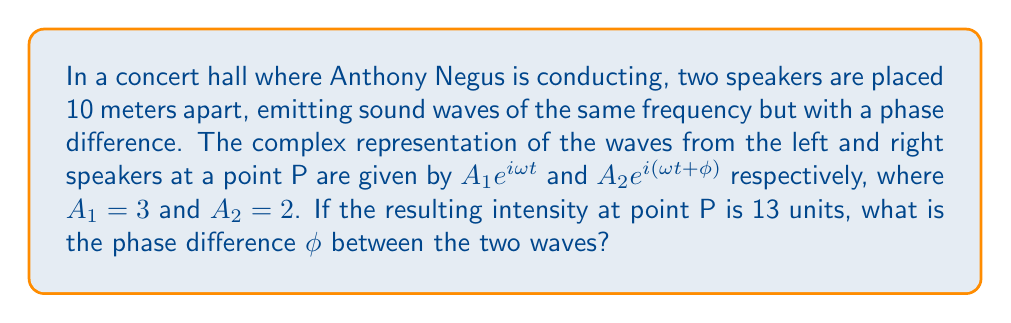Teach me how to tackle this problem. Let's approach this step-by-step:

1) The resulting wave at point P is the sum of the two waves:
   $$A_{total} = A_1e^{i\omega t} + A_2e^{i(\omega t + \phi)}$$

2) We can factor out $e^{i\omega t}$:
   $$A_{total} = e^{i\omega t}(A_1 + A_2e^{i\phi})$$

3) The intensity is proportional to the square of the amplitude:
   $$I \propto |A_{total}|^2 = |A_1 + A_2e^{i\phi}|^2$$

4) Expanding this:
   $$|A_1 + A_2e^{i\phi}|^2 = (A_1 + A_2e^{i\phi})(A_1 + A_2e^{-i\phi})$$
   $$= A_1^2 + A_2^2 + A_1A_2(e^{i\phi} + e^{-i\phi})$$

5) Recall that $e^{i\phi} + e^{-i\phi} = 2\cos\phi$, so:
   $$I = A_1^2 + A_2^2 + 2A_1A_2\cos\phi$$

6) Substituting the known values:
   $$13 = 3^2 + 2^2 + 2(3)(2)\cos\phi$$
   $$13 = 9 + 4 + 12\cos\phi$$

7) Solving for $\cos\phi$:
   $$12\cos\phi = 0$$
   $$\cos\phi = 0$$

8) The solution to this is:
   $$\phi = \frac{\pi}{2}$$ or $$\phi = \frac{3\pi}{2}$$

Since we're looking for the phase difference, we take the smaller positive value.
Answer: $\frac{\pi}{2}$ radians 